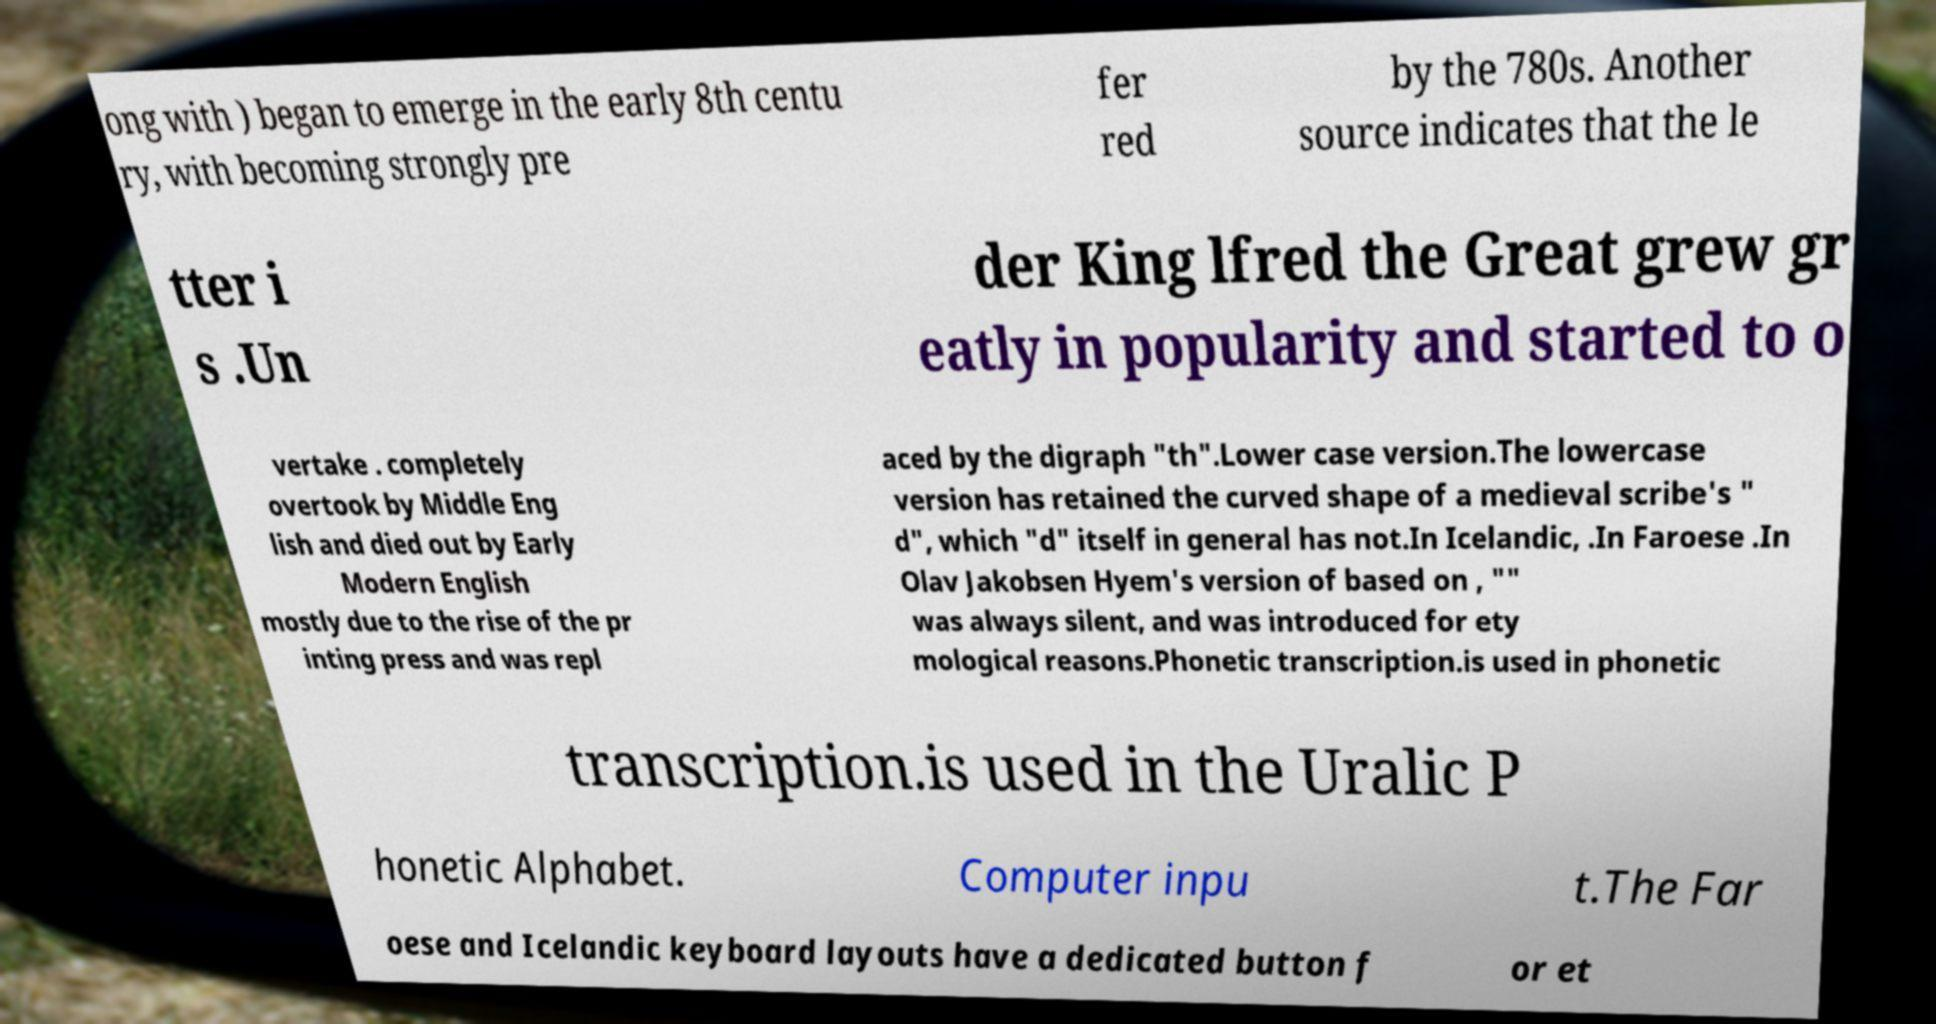There's text embedded in this image that I need extracted. Can you transcribe it verbatim? ong with ) began to emerge in the early 8th centu ry, with becoming strongly pre fer red by the 780s. Another source indicates that the le tter i s .Un der King lfred the Great grew gr eatly in popularity and started to o vertake . completely overtook by Middle Eng lish and died out by Early Modern English mostly due to the rise of the pr inting press and was repl aced by the digraph "th".Lower case version.The lowercase version has retained the curved shape of a medieval scribe's " d", which "d" itself in general has not.In Icelandic, .In Faroese .In Olav Jakobsen Hyem's version of based on , "" was always silent, and was introduced for ety mological reasons.Phonetic transcription.is used in phonetic transcription.is used in the Uralic P honetic Alphabet. Computer inpu t.The Far oese and Icelandic keyboard layouts have a dedicated button f or et 